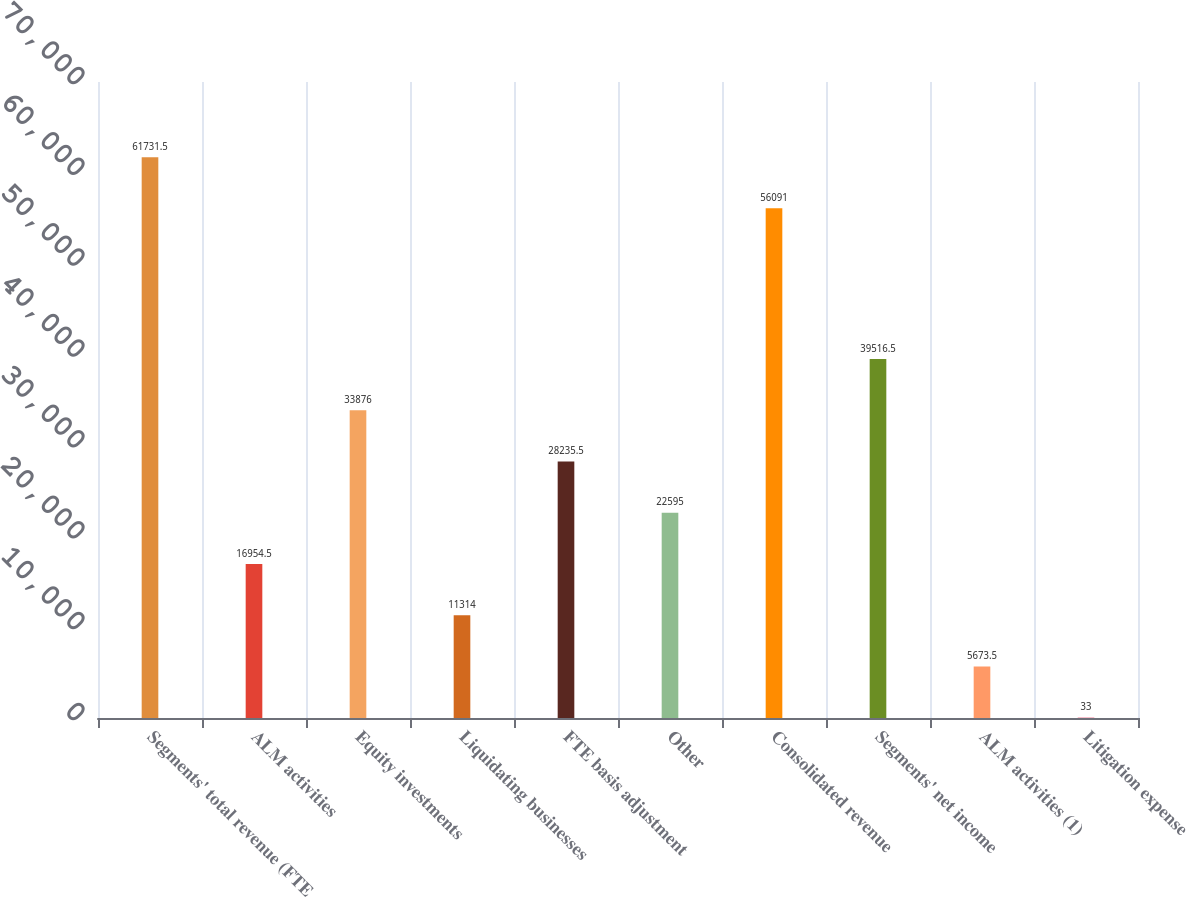<chart> <loc_0><loc_0><loc_500><loc_500><bar_chart><fcel>Segments' total revenue (FTE<fcel>ALM activities<fcel>Equity investments<fcel>Liquidating businesses<fcel>FTE basis adjustment<fcel>Other<fcel>Consolidated revenue<fcel>Segments' net income<fcel>ALM activities (1)<fcel>Litigation expense<nl><fcel>61731.5<fcel>16954.5<fcel>33876<fcel>11314<fcel>28235.5<fcel>22595<fcel>56091<fcel>39516.5<fcel>5673.5<fcel>33<nl></chart> 